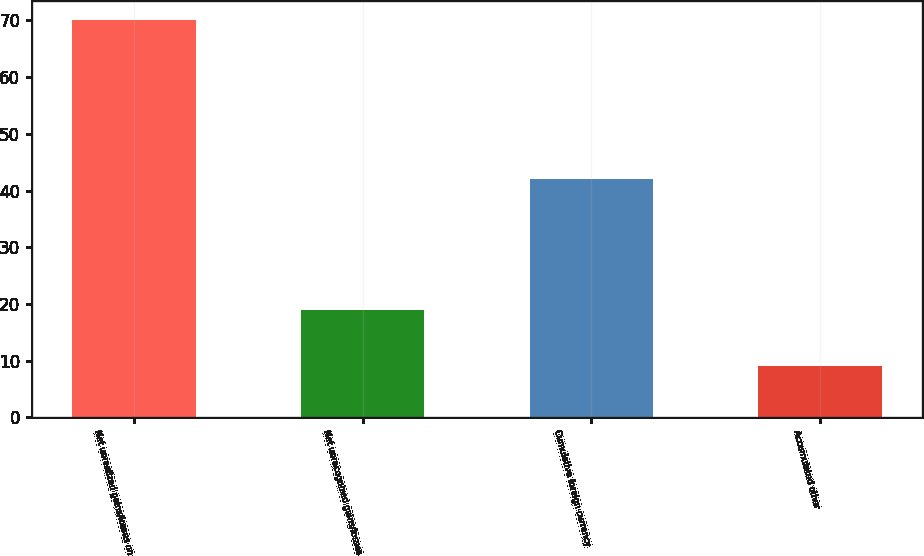<chart> <loc_0><loc_0><loc_500><loc_500><bar_chart><fcel>Net unrealized gains/losses on<fcel>Net unrecognized gains/losses<fcel>Cumulative foreign currency<fcel>Accumulated other<nl><fcel>70<fcel>19<fcel>42<fcel>9<nl></chart> 